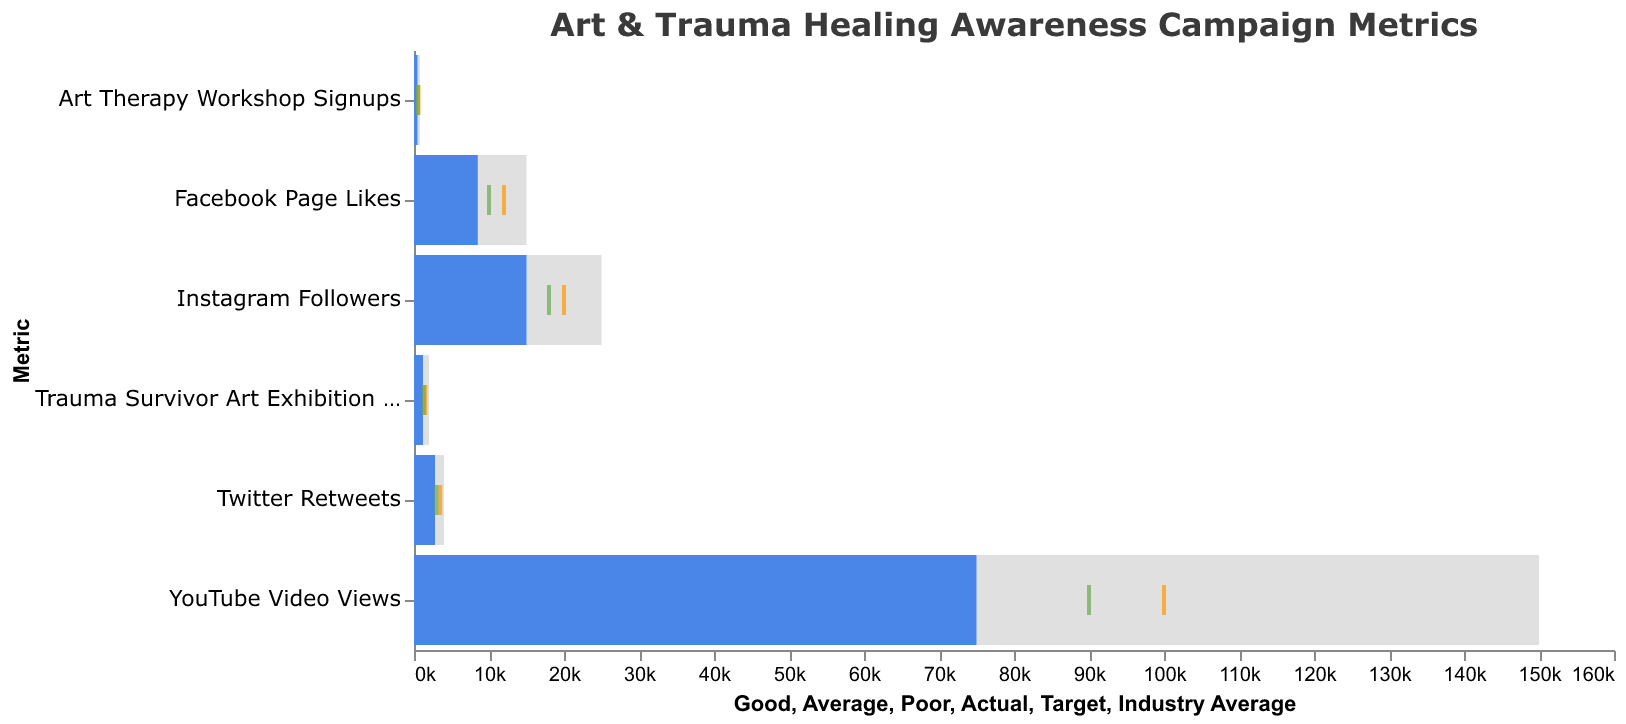What is the title of the chart? The title is displayed at the top of the chart in a larger font size compared to other texts in the chart. The title reads “Art & Trauma Healing Awareness Campaign Metrics”.
Answer: Art & Trauma Healing Awareness Campaign Metrics What is the actual value of Instagram Followers? The actual values are represented by blue bars. Locate the blue bar corresponding to “Instagram Followers” on the y-axis. The length of the bar indicates the value, which is 15,000.
Answer: 15,000 What is the industry average for YouTube Video Views? The industry averages are marked by green ticks. Find the green tick on the "YouTube Video Views" row. The value corresponding to this tick is 90,000.
Answer: 90,000 How many total metrics are displayed on the chart? Count the number of unique entries in the y-axis, which categorizes the different metrics. There are six different metrics shown.
Answer: 6 For which metric is the actual value closest to the industry average? Compare the blue bar representing the actual values against the green ticks representing the industry averages for each metric. The closest proximity is seen in "Twitter Retweets" where the actual value is 2,800 and the industry average is 3,000.
Answer: Twitter Retweets What is the target value for Art Therapy Workshop Signups? Targets are marked by orange ticks. Locate the orange tick on the "Art Therapy Workshop Signups" row. The value indicated by this tick is 600.
Answer: 600 How does the actual value of Facebook Page Likes compare to its target value? The actual value for Facebook Page Likes is represented by a blue bar, which is 8,500, and the target is marked by an orange tick at 12,000. The actual value is less than the target.
Answer: Less than What is the difference between the actual and target values for Trauma Survivor Art Exhibition Attendees? Subtract the actual value (1,200) from the target value (1,500). The difference is 1,500 - 1,200 = 300.
Answer: 300 Which metric has an actual value that falls within the 'Good' range? Compare the actual values (blue bars) to the 'Good' ranges (highest bars in each category). For "YouTube Video Views," the actual value of 75,000 falls within the 'Good' range of 50,000 to 150,000.
Answer: YouTube Video Views What is the range for the 'Average' performance of Twitter Retweets? The 'Average' performance ranges are indicated by the middle grey bars. On the Twitter Retweets row, the 'Average' range is from 1,500 to 4,000.
Answer: 1,500 to 4,000 